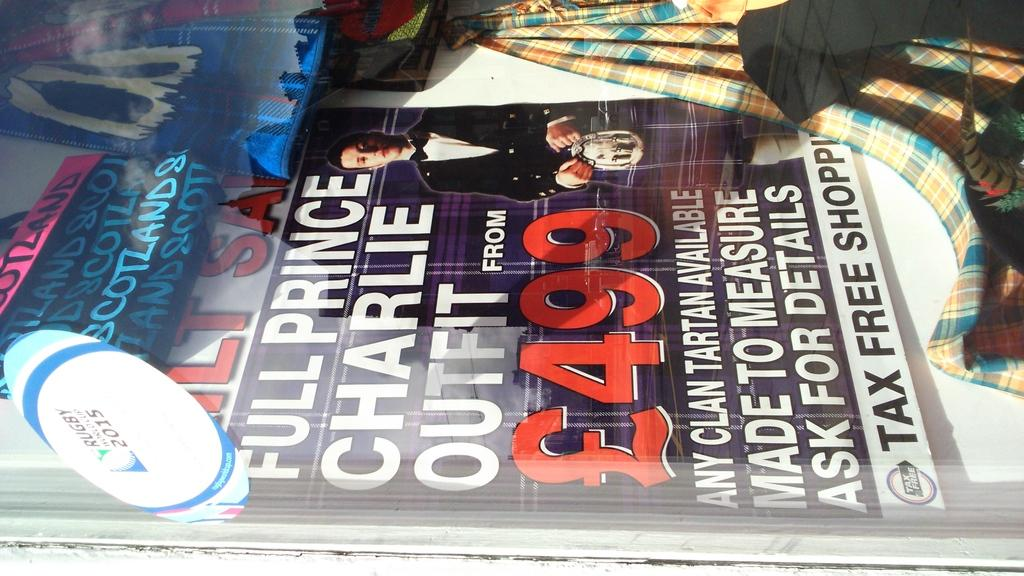Provide a one-sentence caption for the provided image. Magazine cover showing a man and something that costs 499. 